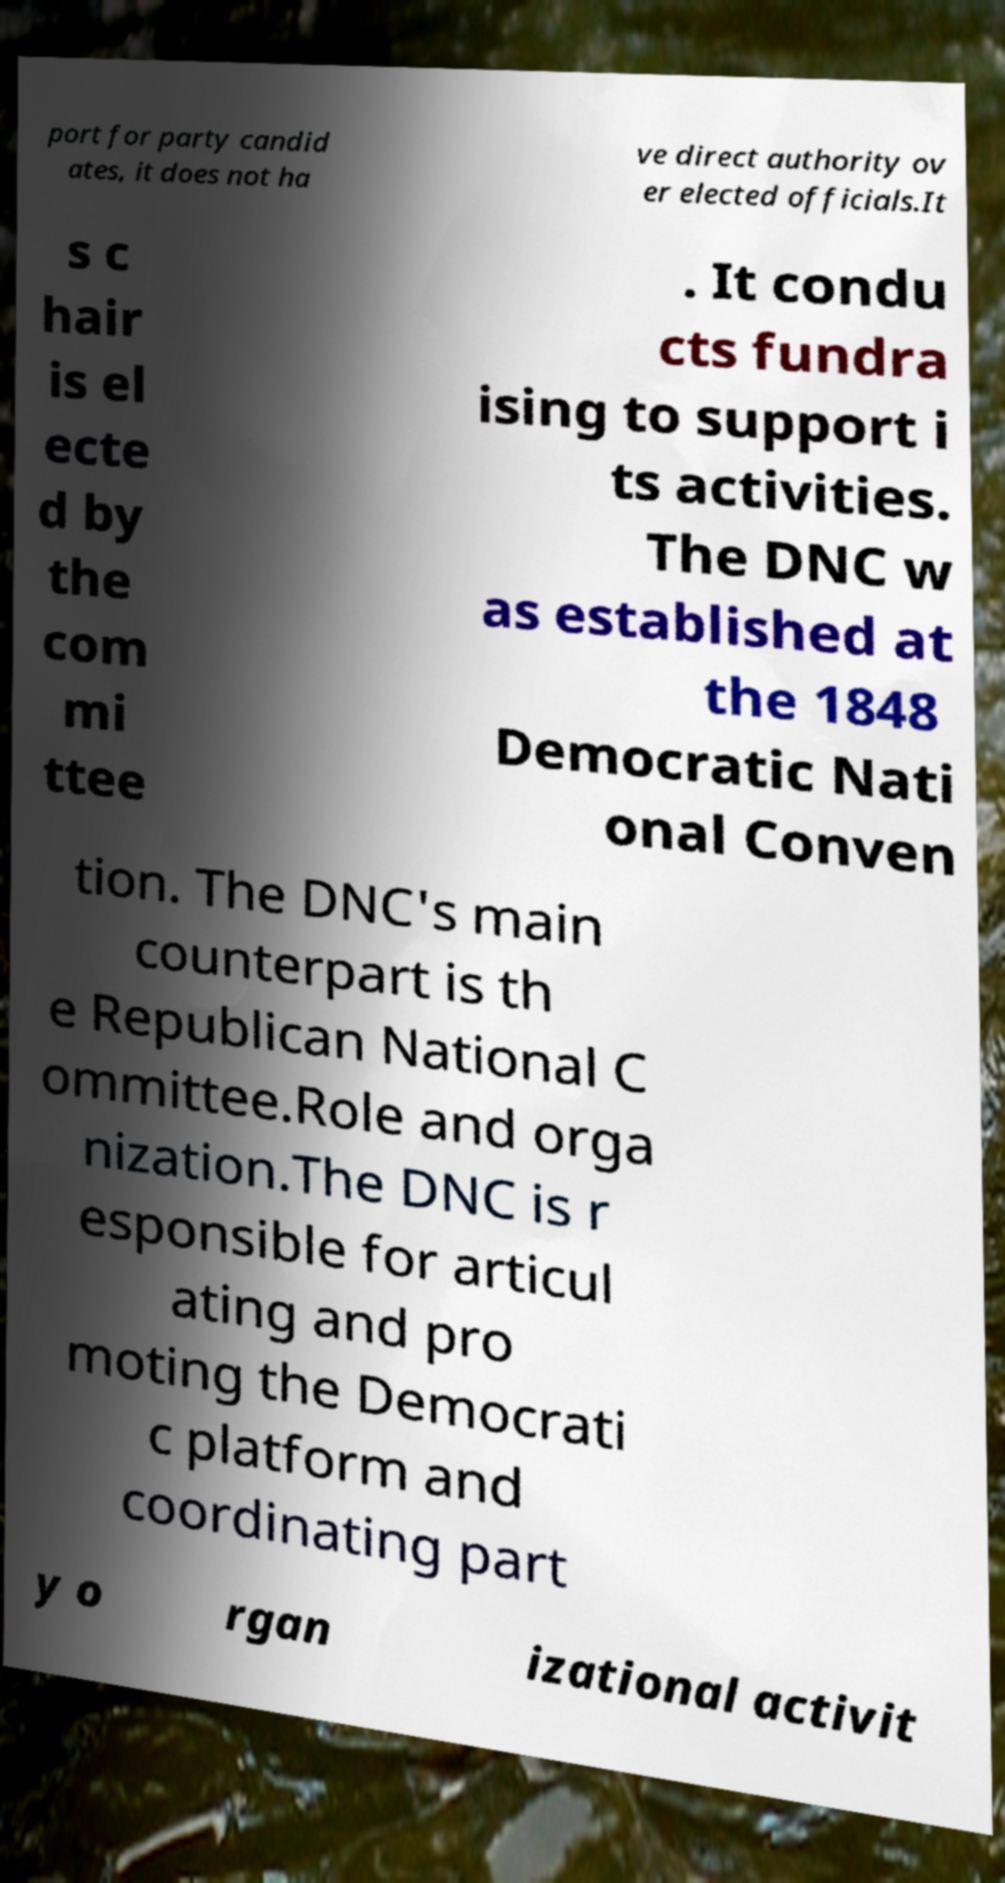Could you assist in decoding the text presented in this image and type it out clearly? port for party candid ates, it does not ha ve direct authority ov er elected officials.It s c hair is el ecte d by the com mi ttee . It condu cts fundra ising to support i ts activities. The DNC w as established at the 1848 Democratic Nati onal Conven tion. The DNC's main counterpart is th e Republican National C ommittee.Role and orga nization.The DNC is r esponsible for articul ating and pro moting the Democrati c platform and coordinating part y o rgan izational activit 